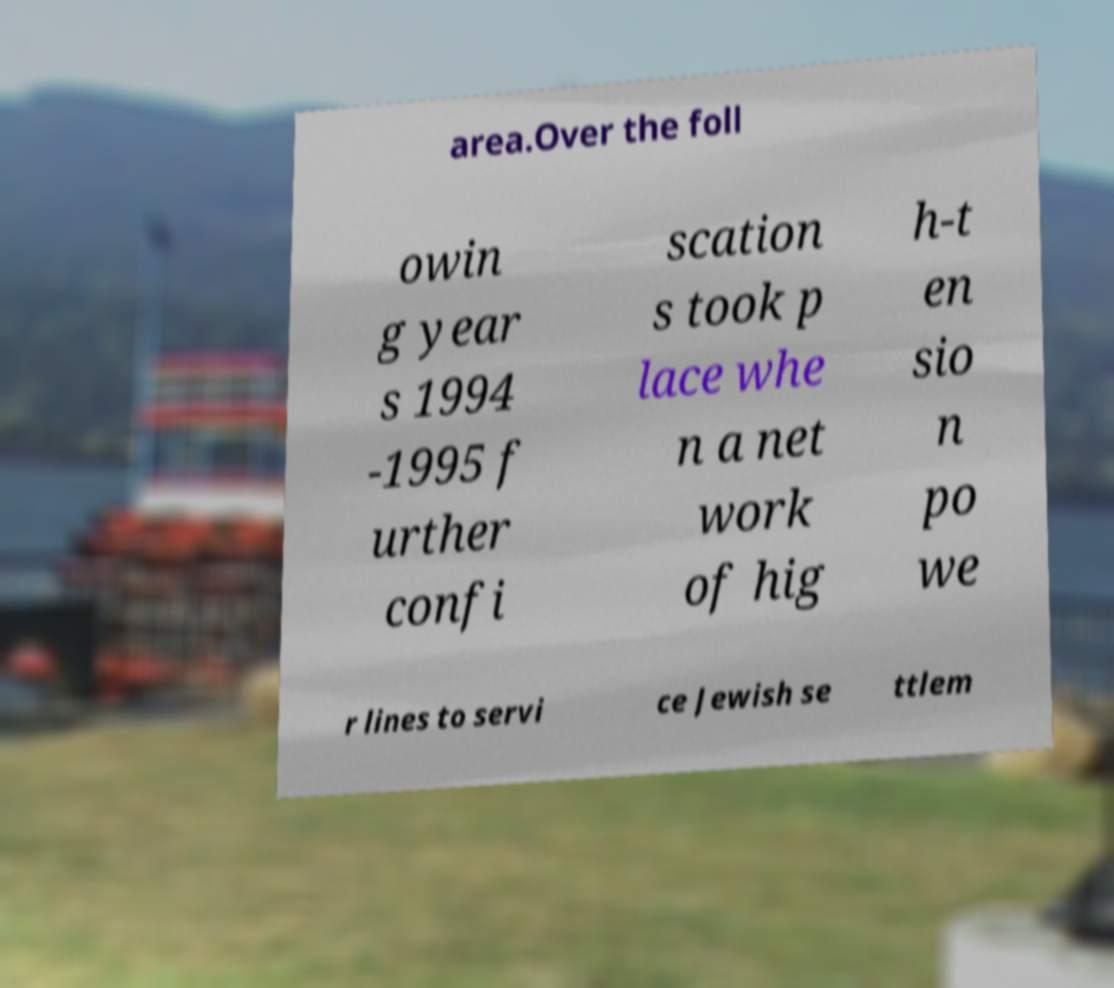Please read and relay the text visible in this image. What does it say? area.Over the foll owin g year s 1994 -1995 f urther confi scation s took p lace whe n a net work of hig h-t en sio n po we r lines to servi ce Jewish se ttlem 